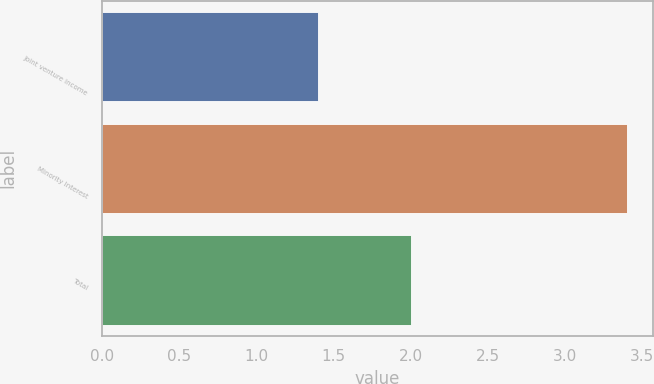<chart> <loc_0><loc_0><loc_500><loc_500><bar_chart><fcel>Joint venture income<fcel>Minority Interest<fcel>Total<nl><fcel>1.4<fcel>3.4<fcel>2<nl></chart> 